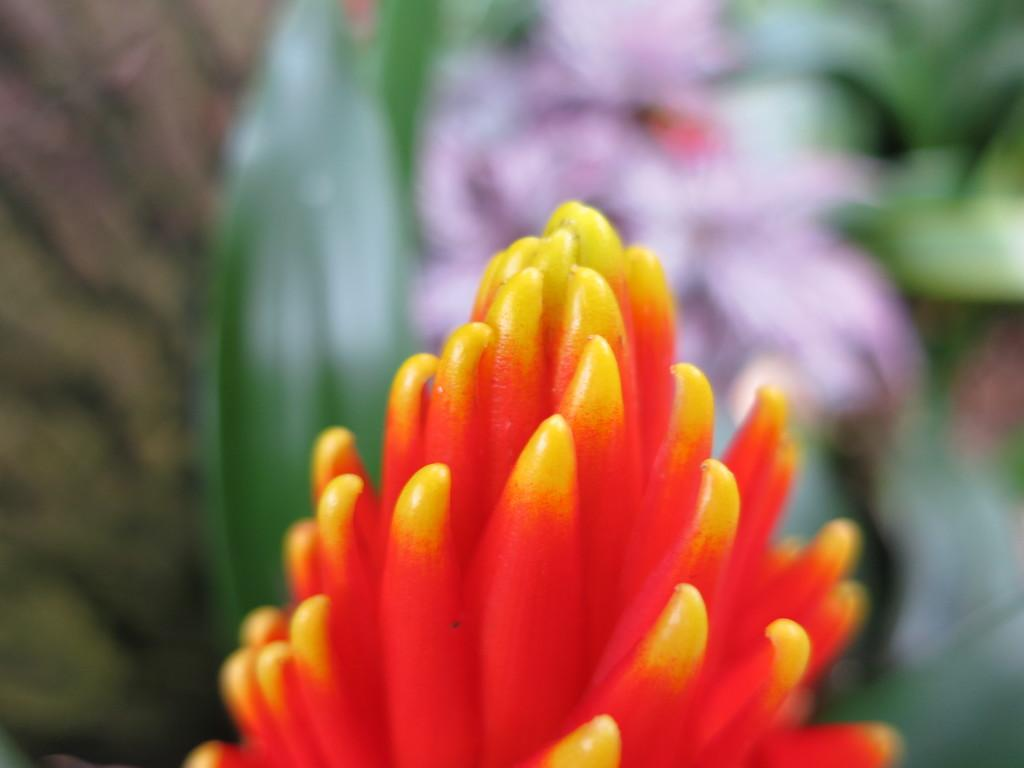What is located at the bottom of the image? There is a flower at the bottom of the image. How would you describe the background of the image? The background of the image is blurred. What can be seen in the background besides the blurred area? Leaves and flowers are visible in the background of the image. What type of feather can be seen illuminating the flower in the image? There is no feather present in the image, and no light source is mentioned that could illuminate the flower. 